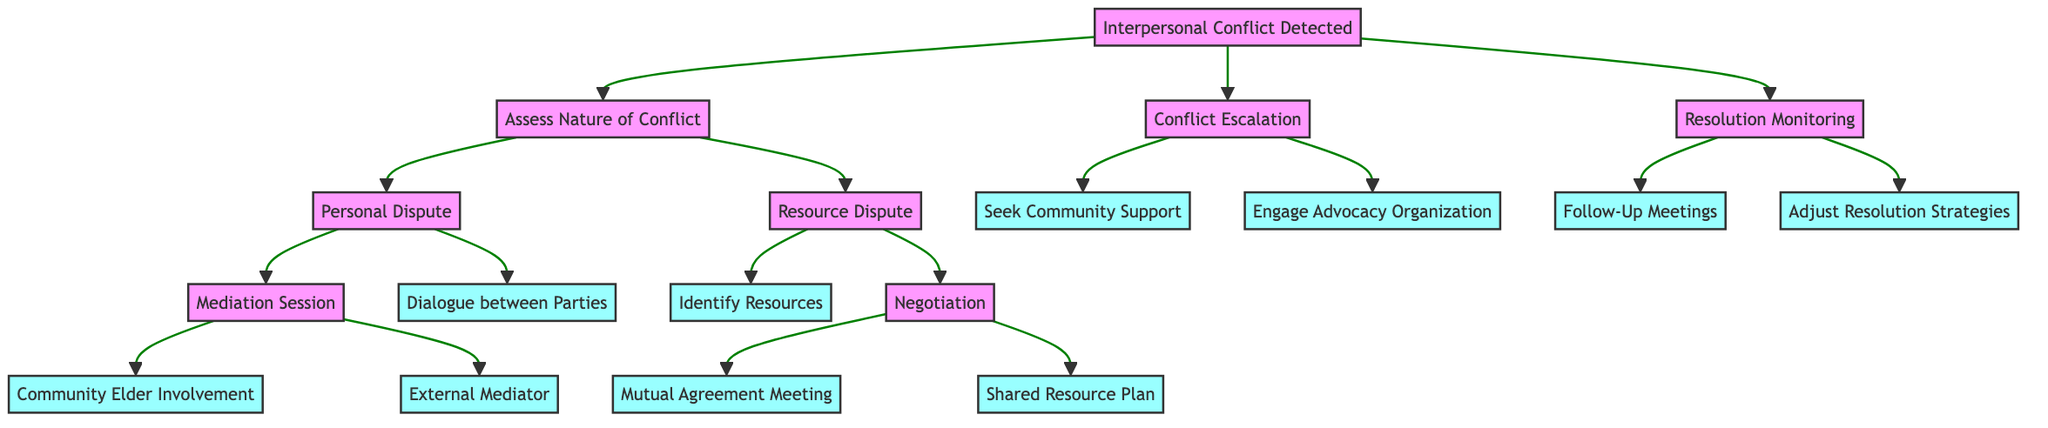What is the first step when interpersonal conflict is detected? The first step in the diagram when interpersonal conflict is detected is "Assess Nature of Conflict." This is shown as the first branching option from the root node.
Answer: Assess Nature of Conflict How many options are presented under "Conflict Escalation"? There are two options presented under the "Conflict Escalation" node: "Seek Community Support" and "Engage Advocacy Organization." These can be counted directly in the diagram.
Answer: 2 What outcome follows "Mediation Session"? The outcomes that follow "Mediation Session" are "Community Elder Involvement" and "External Mediator." These options are depicted as branches from the "Mediation Session" node.
Answer: Community Elder Involvement, External Mediator Which option leads to the "Adjust Resolution Strategies"? The option that leads to "Adjust Resolution Strategies" is "Resolution Monitoring." This is a subsequent node connected from the root node, indicating monitoring strategies after conflict resolution attempts.
Answer: Resolution Monitoring What are the outcomes listed under "Resource Dispute"? The outcomes listed under "Resource Dispute" include "Identify Resources" and "Negotiation." These can be found directly branching off the "Resource Dispute" node in the diagram.
Answer: Identify Resources, Negotiation Which two nodes can be reached from "Personal Dispute"? The two nodes that can be reached from "Personal Dispute" are "Mediation Session" and "Dialogue between Parties." Both are shown as options branching directly from the "Personal Dispute" node.
Answer: Mediation Session, Dialogue between Parties What must occur before monitoring of the resolution process begins? Before monitoring of the resolution process, a resolution must be achieved through one of the preceding conflict management strategies; the diagram indicates that follow-up is part of the "Resolution Monitoring" stage after steps have been taken to resolve the conflict.
Answer: Resolution achieved What outcome does "Negotiation" lead to? "Negotiation" leads to two possible outcomes: "Mutual Agreement Meeting" and "Shared Resource Plan." These are directly indicated as branches coming from the "Negotiation" node.
Answer: Mutual Agreement Meeting, Shared Resource Plan How does "Conflict Escalation" differ from "Assess Nature of Conflict"? "Conflict Escalation" involves seeking additional support or involvement (like community support or advocacy), while "Assess Nature of Conflict" focuses on analyzing and determining the type of conflict present (personal or resource-based) before taking further actions. This difference is evident through the paths branching from these nodes in the diagram.
Answer: Different focus on support vs. analysis 